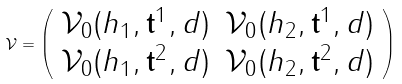<formula> <loc_0><loc_0><loc_500><loc_500>\mathcal { V } = \left ( \begin{array} { c c } \mathcal { V } _ { 0 } ( h _ { 1 } , \mathbf t ^ { 1 } , d ) & \mathcal { V } _ { 0 } ( h _ { 2 } , \mathbf t ^ { 1 } , d ) \\ \mathcal { V } _ { 0 } ( h _ { 1 } , \mathbf t ^ { 2 } , d ) & \mathcal { V } _ { 0 } ( h _ { 2 } , \mathbf t ^ { 2 } , d ) \end{array} \right )</formula> 